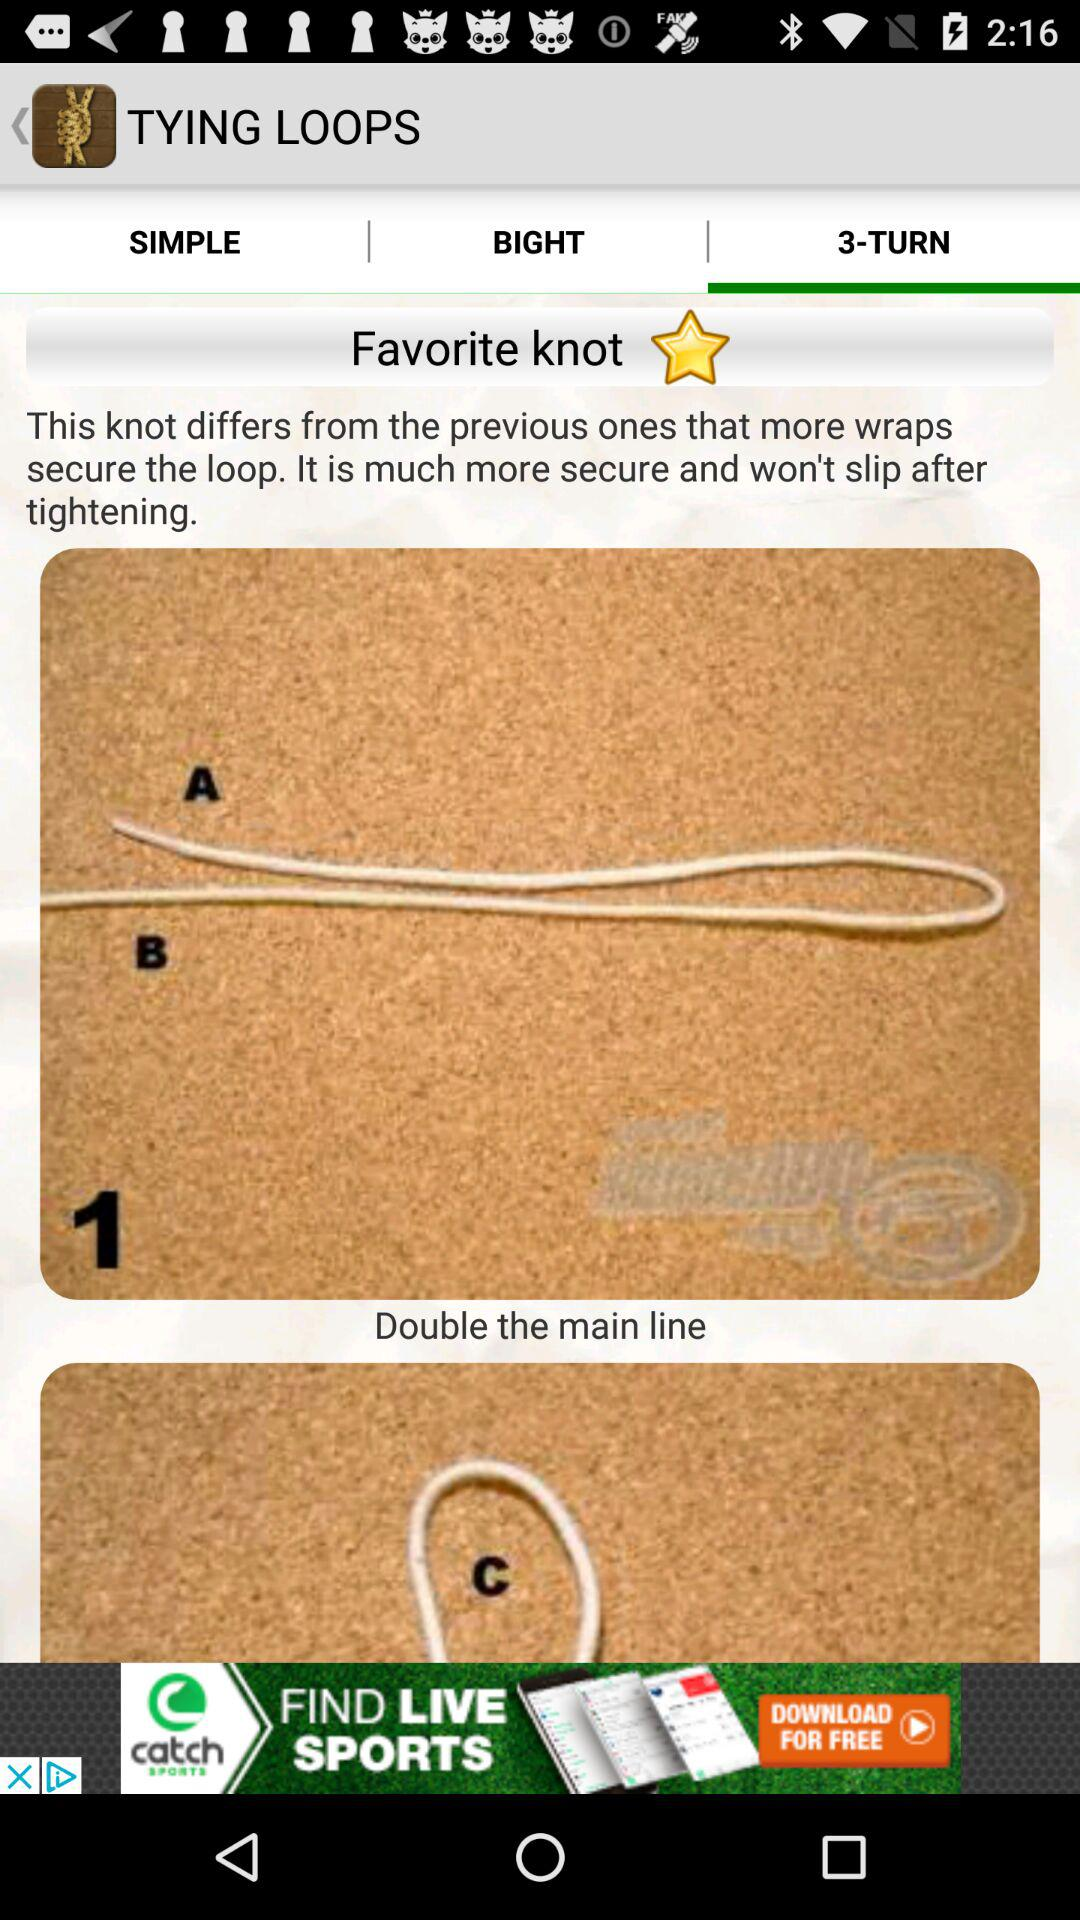Which tab is selected? The selected tab is "3-TURN". 